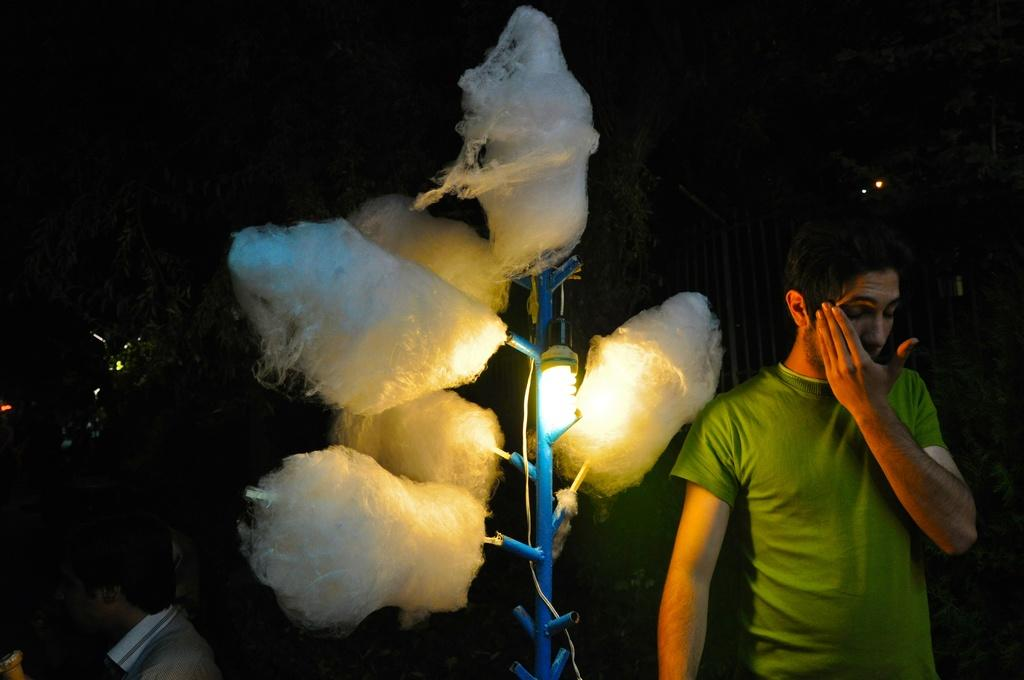How many people are in the image? There are two persons in the image. What can be seen in the image besides the people? There is a stand with a light in the image. What is located near the person in the image? There are objects beside the person in the image. What is the color of the background in the image? The background of the image is dark. Can you see a rabbit's nest in the image? There is no rabbit or nest present in the image. What is the desire of the person in the image? The image does not provide information about the desires of the person, as it only shows their physical appearance and the objects around them. 